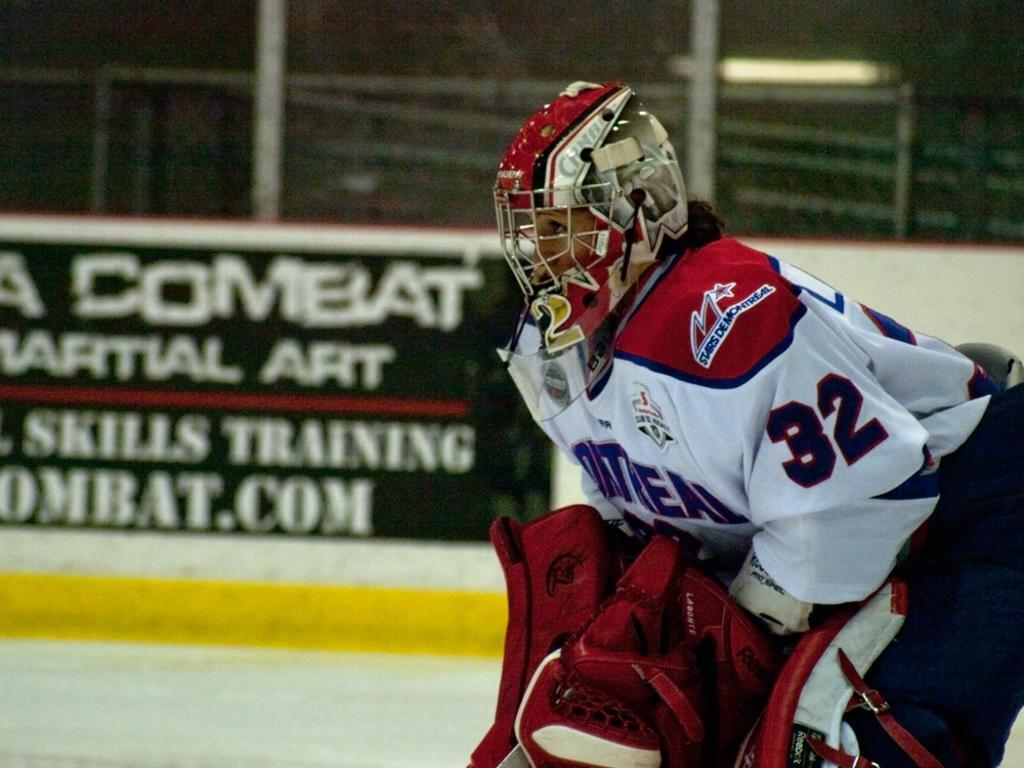Please provide a concise description of this image. In this image we can see a sports person wearing a helmet. In the background there is a board and we can see a fence. 